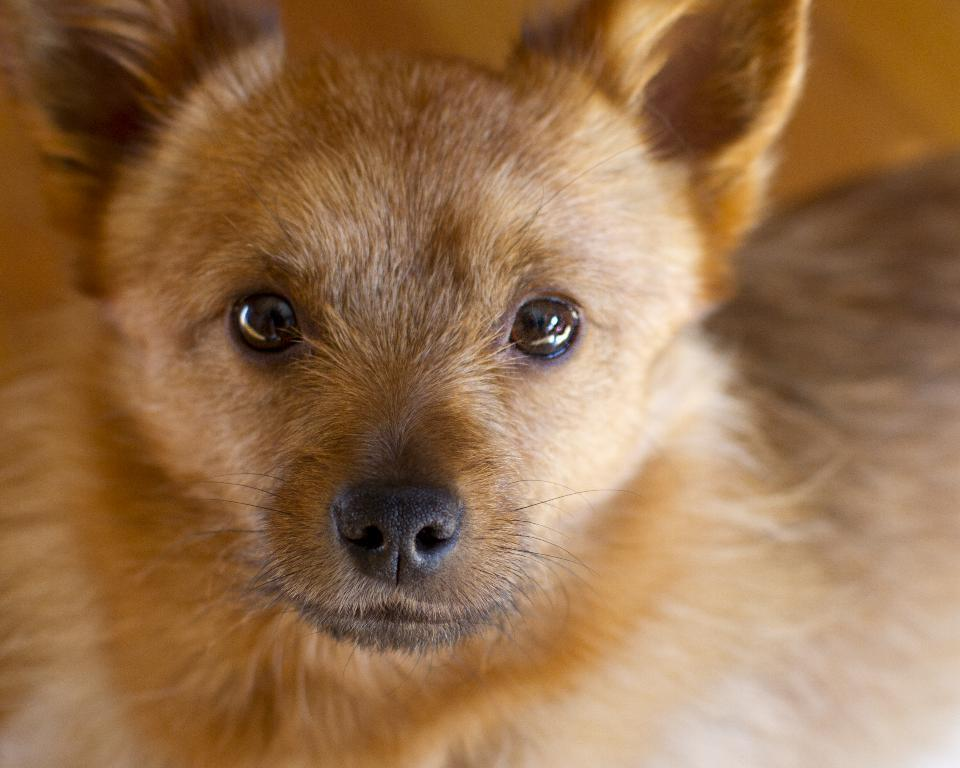What type of creature is present in the image? There is an animal in the image. Can you describe the color of the animal? The animal is brown in color. What type of crate is the animal sitting in the image? There is no crate present in the image; it only features an animal. 